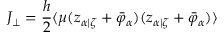<formula> <loc_0><loc_0><loc_500><loc_500>J _ { \perp } = \frac { h } { 2 } \langle \mu ( z _ { \alpha | \zeta } + \bar { \varphi } _ { \alpha } ) ( z _ { \alpha | \zeta } + \bar { \varphi } _ { \alpha } ) \rangle</formula> 